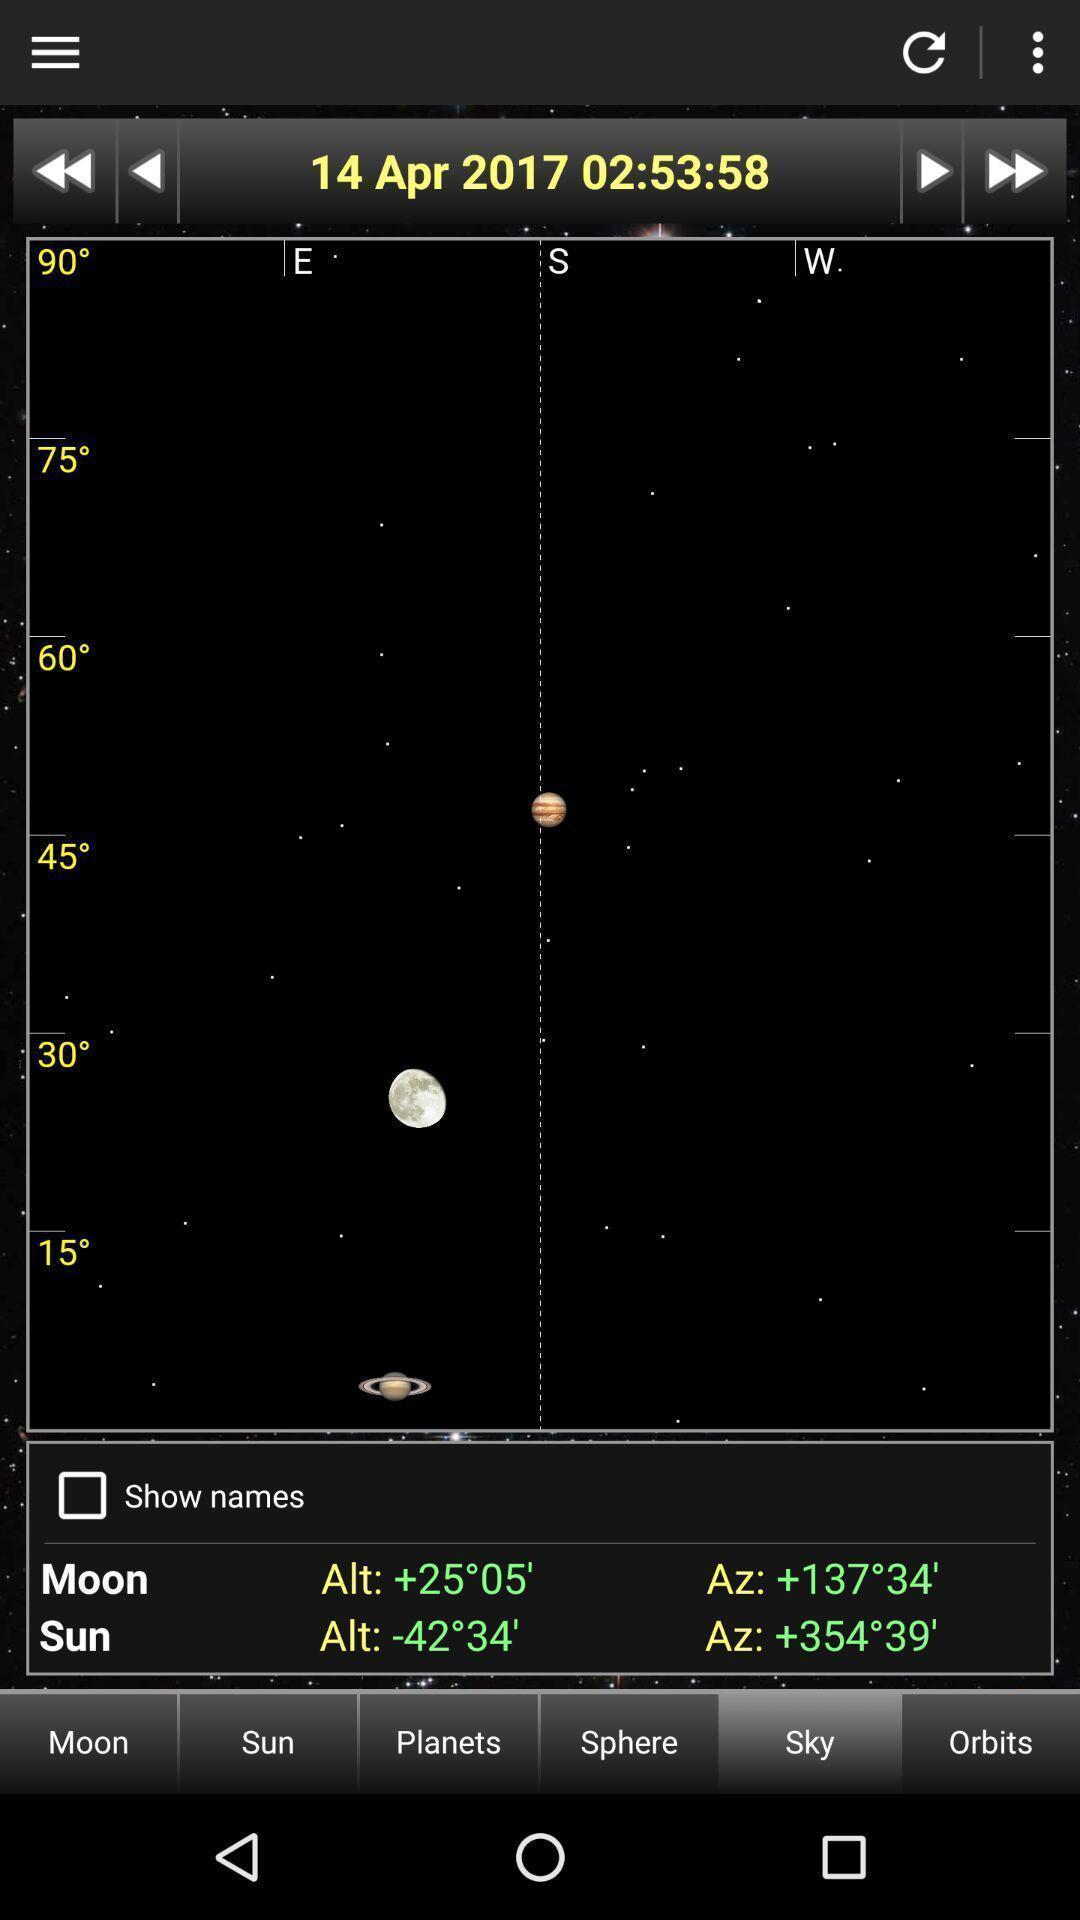Tell me about the visual elements in this screen capture. Page displays degree between sun and moon. 